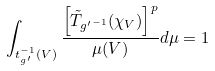Convert formula to latex. <formula><loc_0><loc_0><loc_500><loc_500>\int _ { t ^ { - 1 } _ { g ^ { \prime } } ( V ) } \frac { \left [ { \tilde { T } } _ { { g ^ { \prime } } ^ { - 1 } } ( \chi _ { V } ) \right ] ^ { p } } { \mu ( V ) } d \mu = 1</formula> 